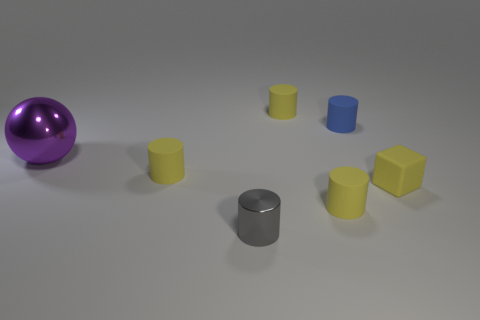Is there anything else that is the same size as the metallic ball?
Your response must be concise. No. What size is the blue rubber object that is the same shape as the gray metal thing?
Offer a terse response. Small. Are there more large metal balls that are behind the blue cylinder than gray rubber cylinders?
Provide a short and direct response. No. What material is the cube?
Offer a very short reply. Rubber. What shape is the tiny gray object that is the same material as the large ball?
Provide a short and direct response. Cylinder. There is a rubber thing left of the small yellow cylinder that is behind the big purple object; what is its size?
Offer a very short reply. Small. There is a small rubber object in front of the block; what color is it?
Keep it short and to the point. Yellow. Is there a yellow thing of the same shape as the gray metallic thing?
Provide a short and direct response. Yes. Are there fewer gray cylinders that are in front of the small metal thing than tiny rubber cubes that are behind the tiny blue cylinder?
Offer a very short reply. No. What color is the large object?
Make the answer very short. Purple. 